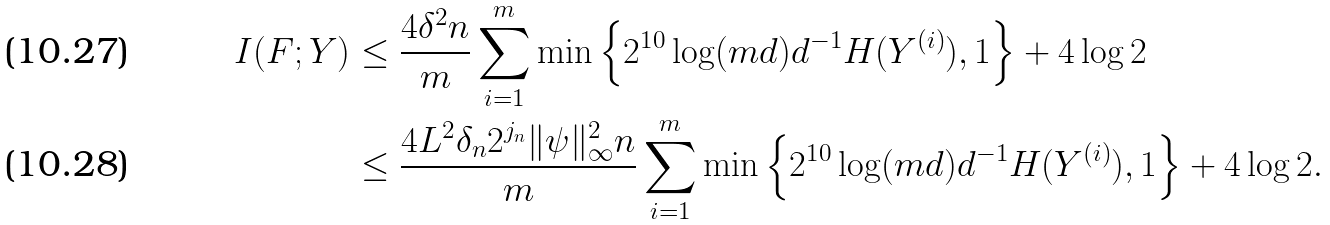<formula> <loc_0><loc_0><loc_500><loc_500>I ( F ; Y ) & \leq \frac { 4 \delta ^ { 2 } n } { m } \sum _ { i = 1 } ^ { m } \min \left \{ 2 ^ { 1 0 } \log ( m d ) d ^ { - 1 } H ( Y ^ { ( i ) } ) , 1 \right \} + 4 \log 2 \\ & \leq \frac { 4 L ^ { 2 } \delta _ { n } 2 ^ { j _ { n } } \| \psi \| _ { \infty } ^ { 2 } n } { m } \sum _ { i = 1 } ^ { m } \min \left \{ 2 ^ { 1 0 } \log ( m d ) d ^ { - 1 } H ( Y ^ { ( i ) } ) , 1 \right \} + 4 \log 2 .</formula> 